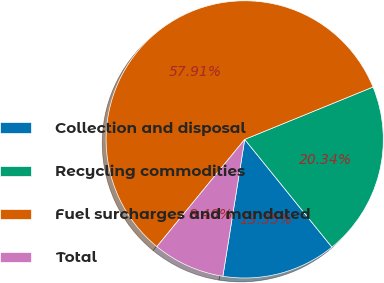<chart> <loc_0><loc_0><loc_500><loc_500><pie_chart><fcel>Collection and disposal<fcel>Recycling commodities<fcel>Fuel surcharges and mandated<fcel>Total<nl><fcel>13.35%<fcel>20.34%<fcel>57.91%<fcel>8.4%<nl></chart> 